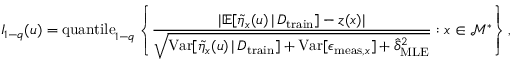Convert formula to latex. <formula><loc_0><loc_0><loc_500><loc_500>I _ { 1 - q } ( u ) = q u a n t i l e _ { 1 - q } \left \{ \frac { | \mathbb { E } [ \tilde { \eta } _ { x } ( u ) \, | \, D _ { t r a i n } ] - z ( x ) | } { \sqrt { V a r [ \tilde { \eta } _ { x } ( u ) \, | \, D _ { t r a i n } ] + V a r [ \epsilon _ { m e a s , x } ] + \hat { \delta } _ { M L E } ^ { 2 } } } \colon x \in \mathcal { M } ^ { * } \right \} ,</formula> 